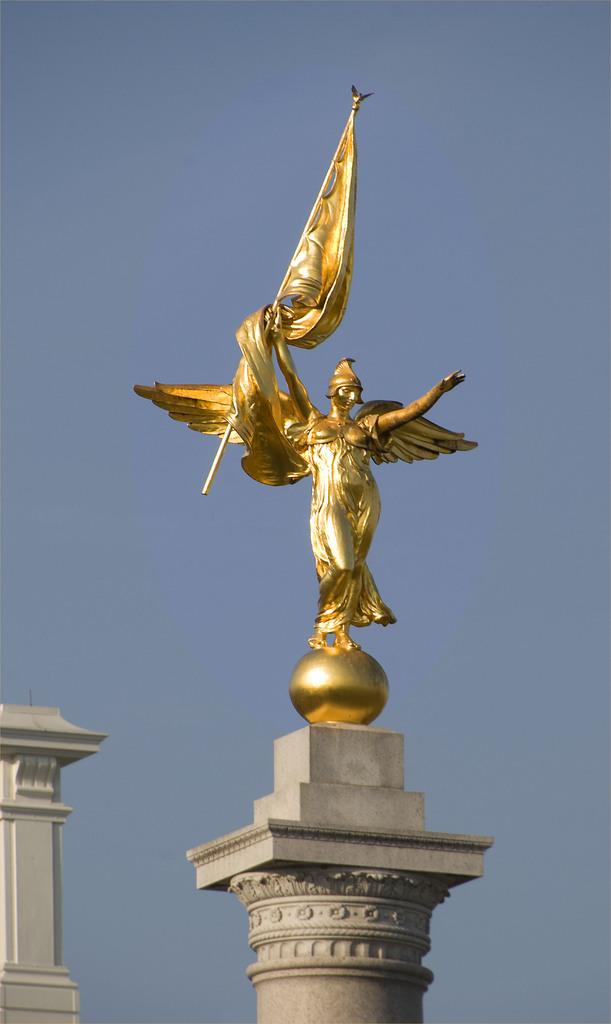What is the main subject of the image? The main subject of the image is a pillar with a statue. What can be seen in the background of the image? The sky is visible in the background of the image. Are there any other pillars in the image? Yes, there is another pillar in the bottom left corner of the image. What is the surprise element in the image? There is no surprise element mentioned in the provided facts, so we cannot determine if there is one in the image. 